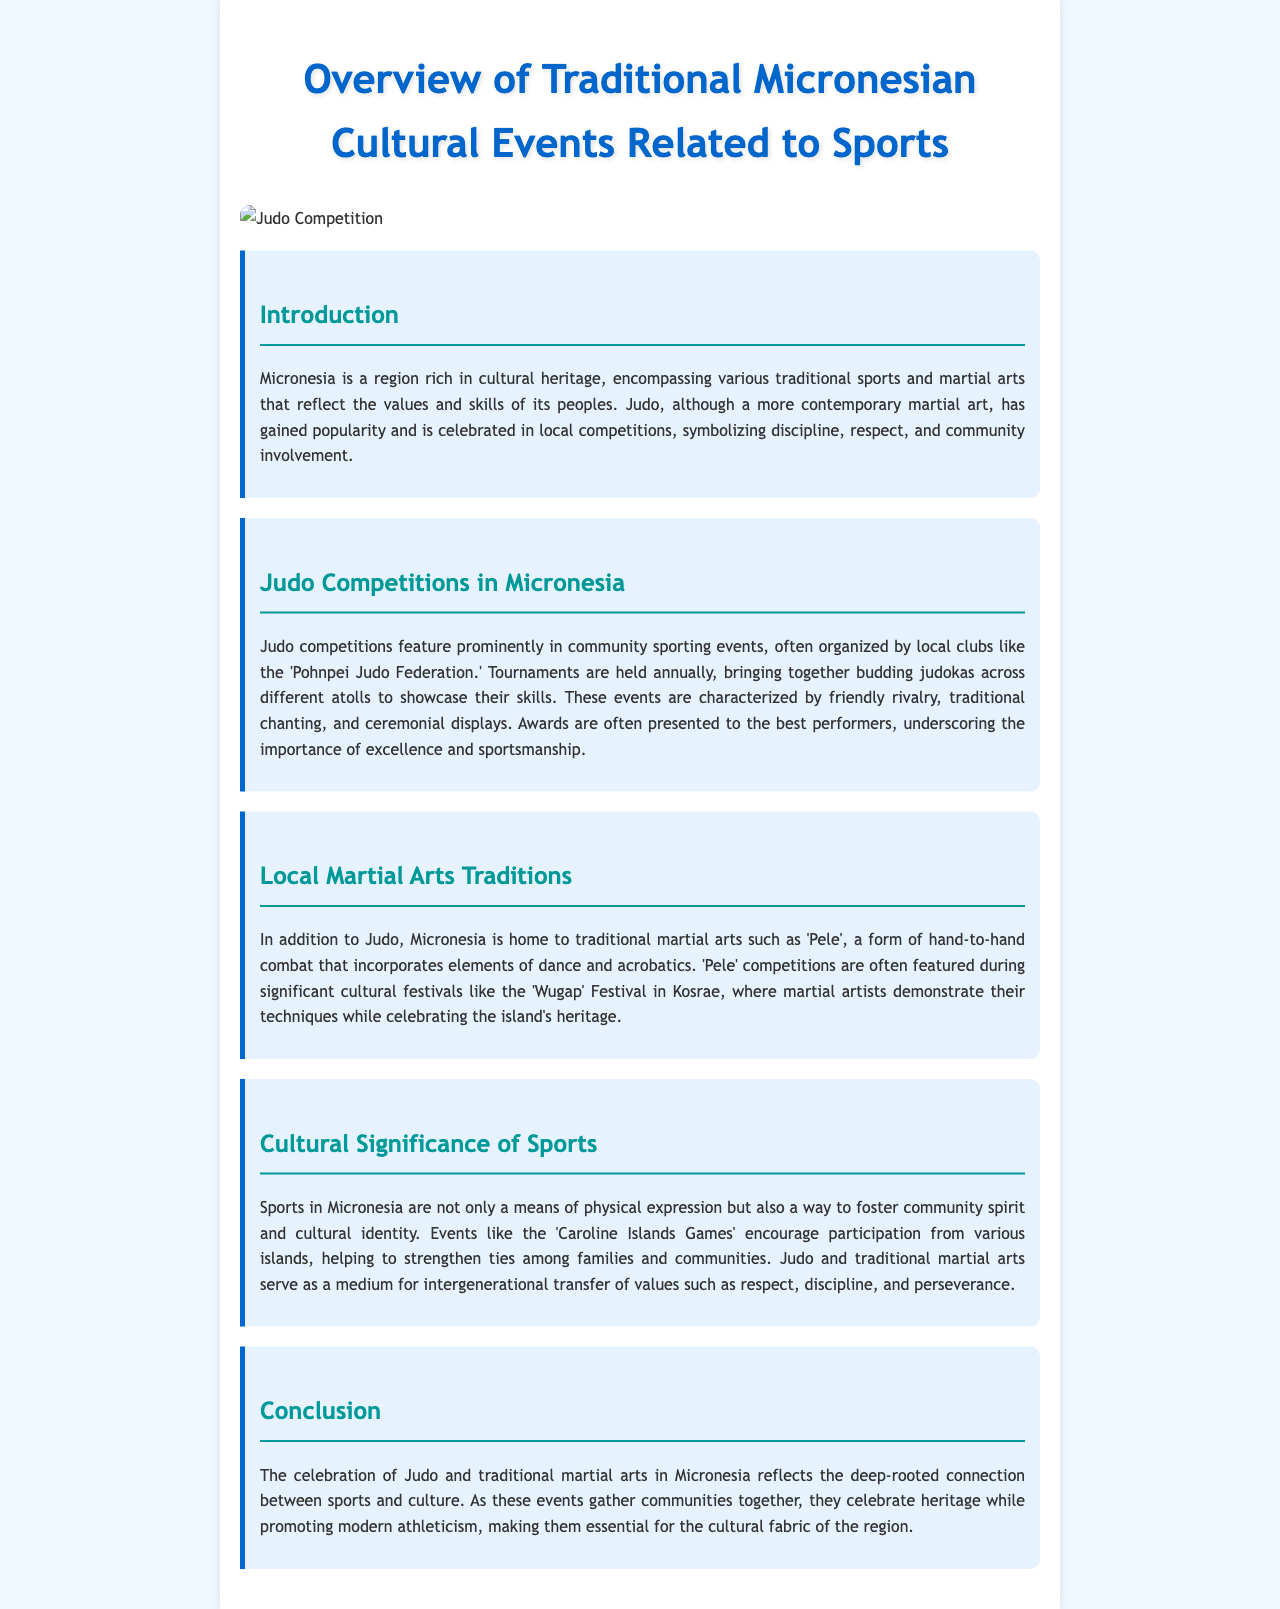What is the name of the local judo federation? The name of the local judo federation mentioned in the document is 'Pohnpei Judo Federation.'
Answer: Pohnpei Judo Federation What does Judo symbolize in Micronesia? In the document, Judo is described as symbolizing discipline, respect, and community involvement.
Answer: Discipline, respect, and community involvement What martial art is mentioned alongside Judo? The document references 'Pele' as a traditional martial art alongside Judo.
Answer: Pele During which cultural festival are 'Pele' competitions held? The 'Wugap' Festival in Kosrae is mentioned as the event where 'Pele' competitions are featured.
Answer: Wugap Festival What is the name of the sporting event that encourages participation from various islands? The document refers to the 'Caroline Islands Games' as the event encouraging such participation.
Answer: Caroline Islands Games What is a key value promoted through Judo and martial arts in Micronesia? The document highlights respect, discipline, and perseverance as essential values taught through these sports.
Answer: Respect, discipline, and perseverance How often are judo tournaments held? Judo tournaments in Micronesia are described as being held annually in the document.
Answer: Annually What type of events do judo competitions feature prominently in? Judo competitions prominently feature community sporting events as stated in the document.
Answer: Community sporting events 